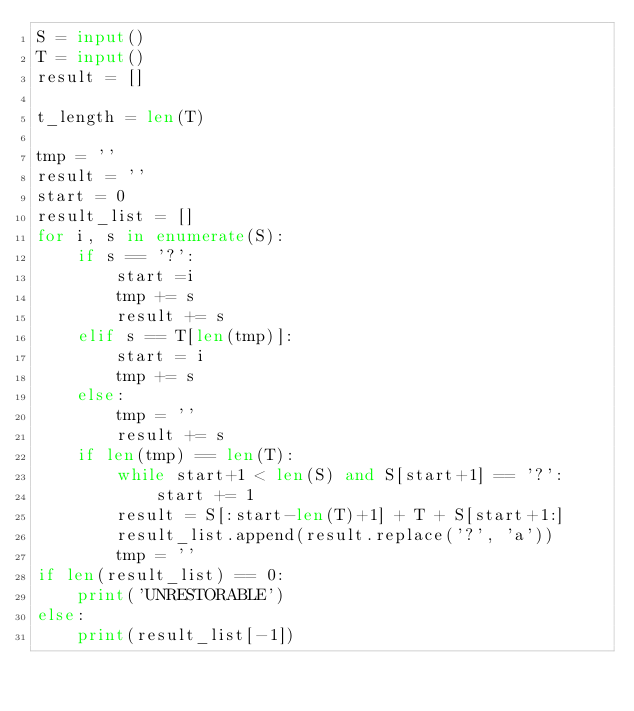<code> <loc_0><loc_0><loc_500><loc_500><_Python_>S = input()
T = input()
result = []

t_length = len(T)

tmp = ''
result = ''
start = 0
result_list = []
for i, s in enumerate(S):
    if s == '?':
        start =i
        tmp += s
        result += s
    elif s == T[len(tmp)]:
        start = i
        tmp += s
    else:
        tmp = ''
        result += s
    if len(tmp) == len(T):
        while start+1 < len(S) and S[start+1] == '?':
            start += 1
        result = S[:start-len(T)+1] + T + S[start+1:]
        result_list.append(result.replace('?', 'a'))
        tmp = ''
if len(result_list) == 0:
    print('UNRESTORABLE')
else:
    print(result_list[-1])</code> 